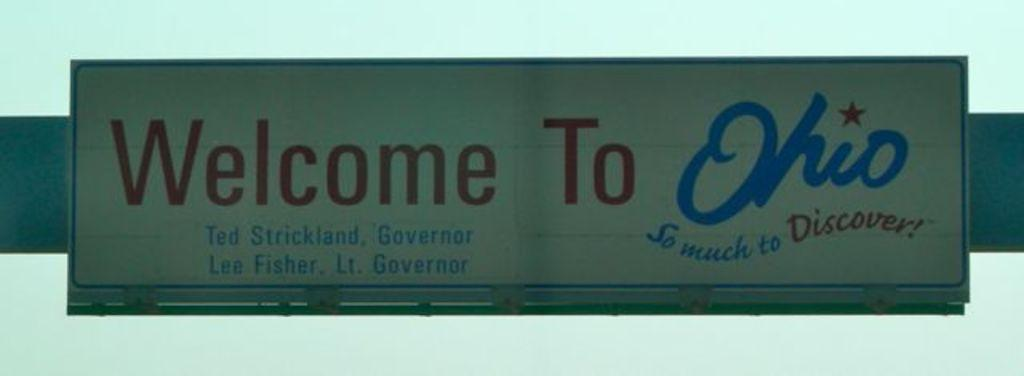<image>
Present a compact description of the photo's key features. A worn looking white sign above reads "Welcome to Ohio". 